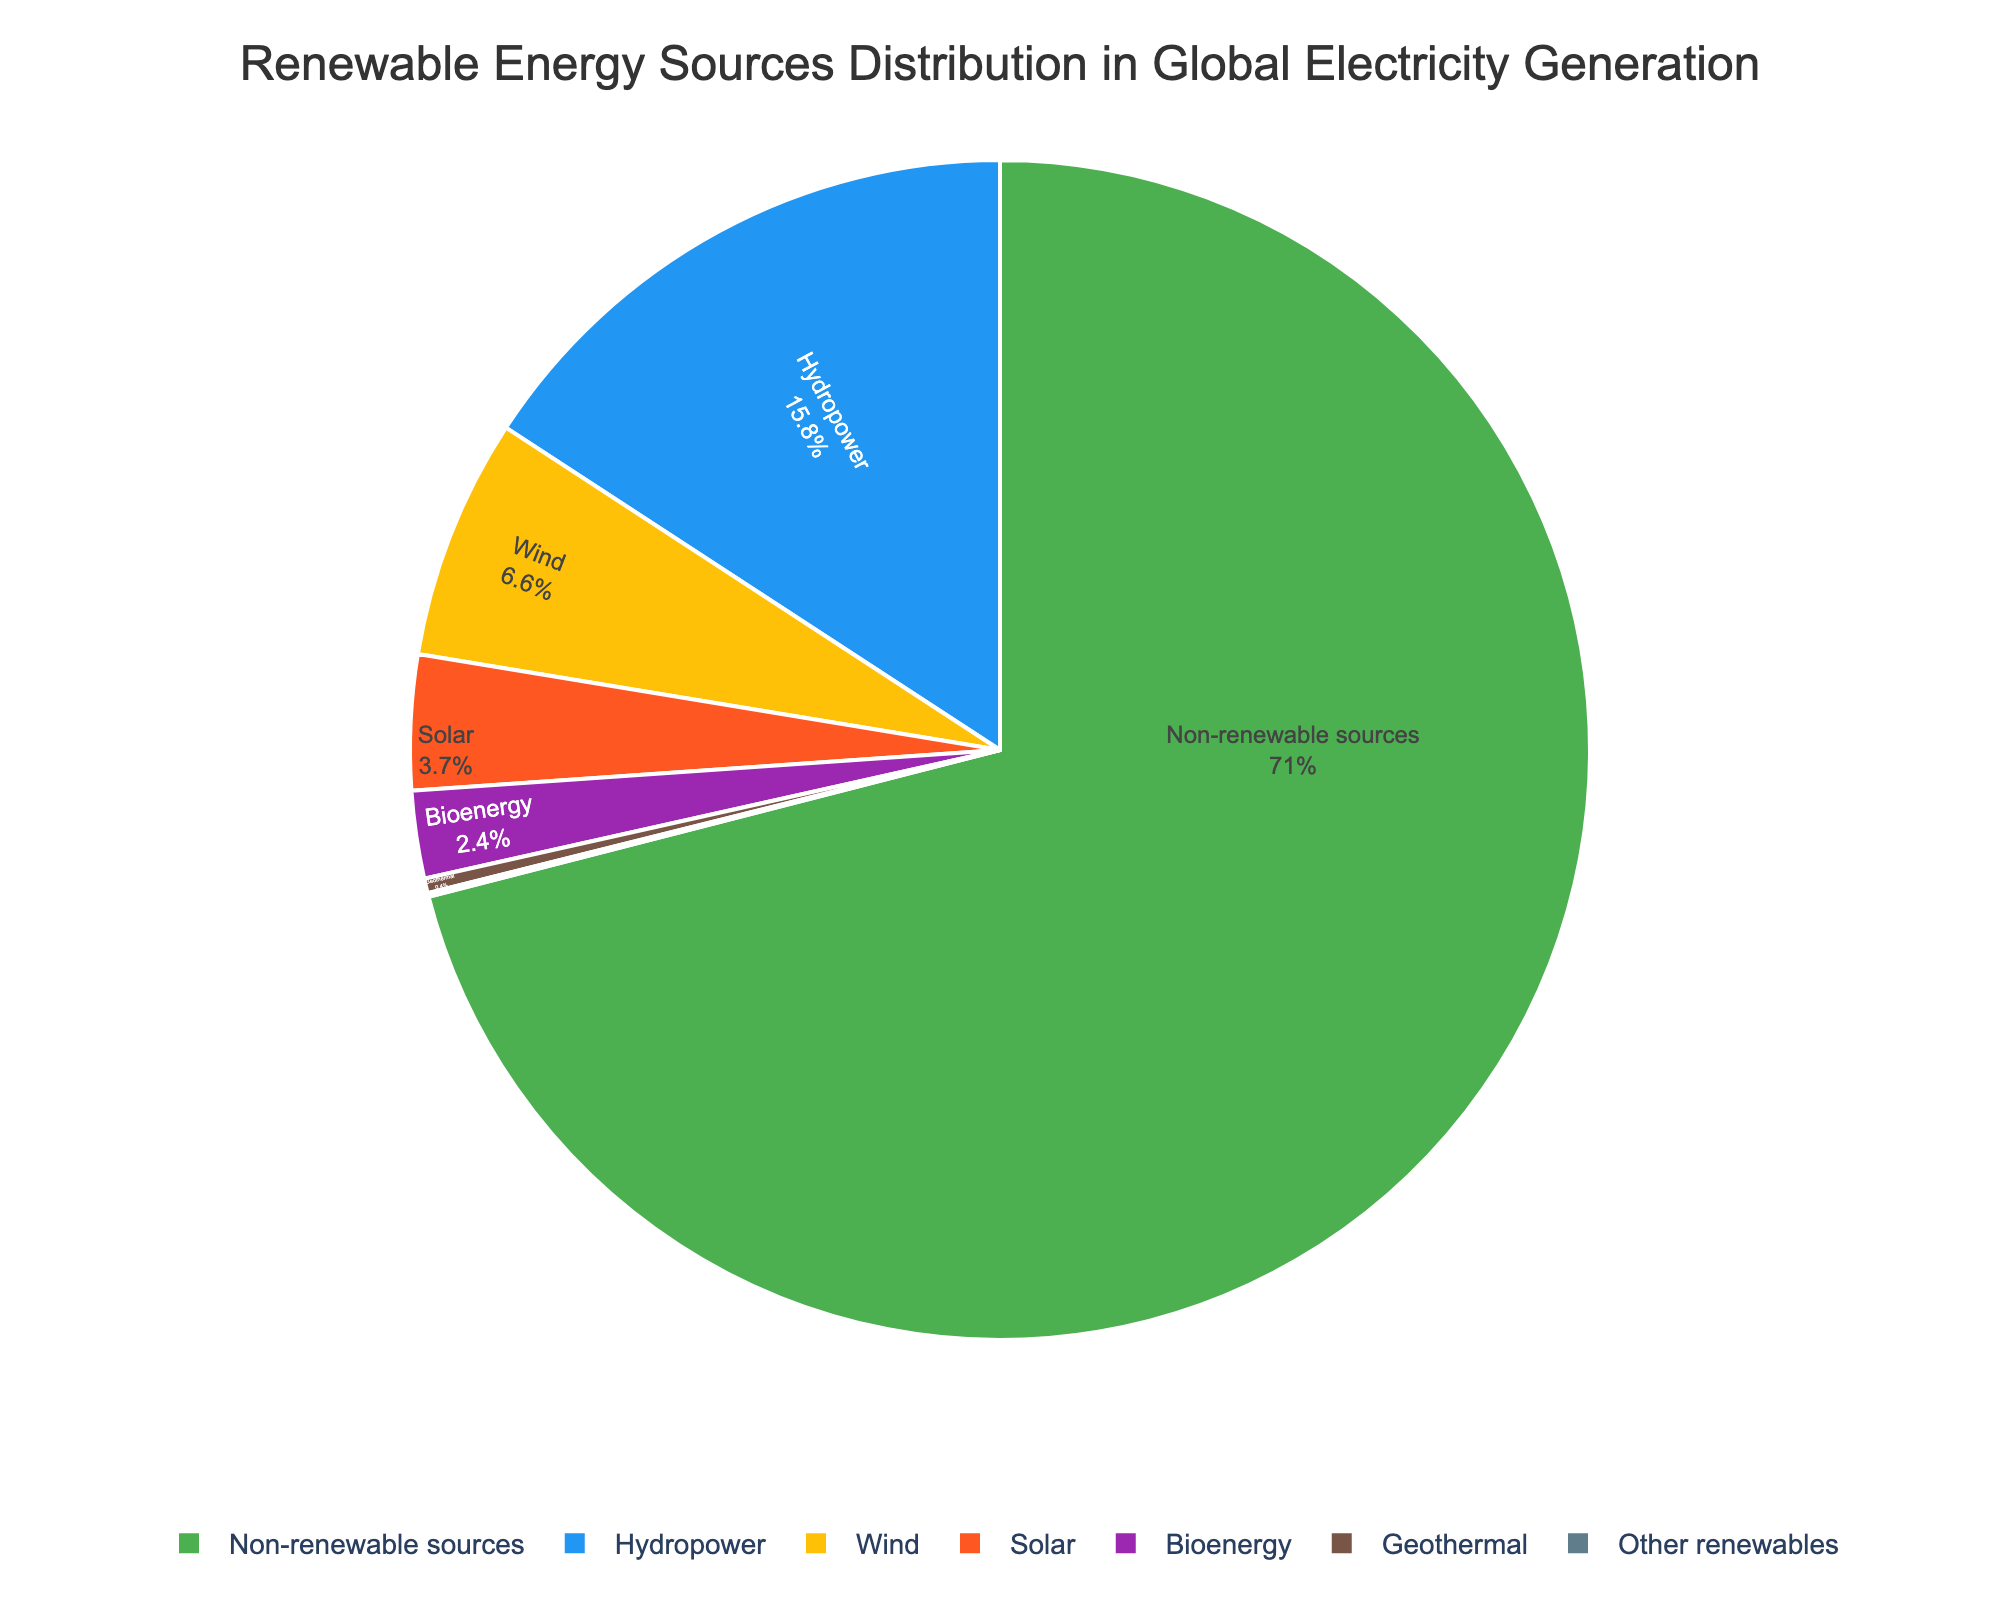Which renewable energy source has the highest percentage in the pie chart? The pie chart shows the percentages of different renewable energy sources in global electricity generation. Hydropower has the largest segment.
Answer: Hydropower Which renewable energy source has the smallest percentage in the pie chart? The pie chart indicates percentages of various renewable energy sources. 'Other renewables' has the smallest segment.
Answer: Other renewables How does the combined percentage of wind and solar compare to hydropower? First, add the percentages of wind (6.6%) and solar (3.7%) which total 10.3%. Then compare this with the percentage of hydropower (15.8%). Hydropower has a higher percentage.
Answer: Hydropower has a higher percentage What is the total percentage of renewable energy sources in the pie chart? Add all the percentages of renewable energy sources: Hydropower (15.8%) + Wind (6.6%) + Solar (3.7%) + Bioenergy (2.4%) + Geothermal (0.4%) + Other renewables (0.1%) = 29%.
Answer: 29% Which category occupies the most space in the pie chart, renewable sources or non-renewable sources? Compare the total percentage of renewable sources (29%) with the percentage of non-renewable sources (71%). Non-renewable sources occupy the largest space.
Answer: Non-renewable sources What is the combined percentage of sources other than wind and solar? Add all percentages except wind (6.6%) and solar (3.7%): 15.8 + 2.4 + 0.4 + 0.1 + 71 = 89.7.
Answer: 89.7% How many times larger is the percentage of non-renewable sources compared to bioenergy? Divide the percentage of non-renewable sources (71%) by the percentage of bioenergy (2.4%): 71 / 2.4 ≈ 29.58.
Answer: Approximately 29.58 times Which color represents wind energy in the pie chart? The color at the segment labeled 'Wind' in the pie chart is blue.
Answer: Blue Is the combined percentage of hydropower, wind, and solar greater than 25%? Add the percentages of hydropower (15.8%), wind (6.6%), and solar (3.7%): 15.8 + 6.6 + 3.7 = 26.1. This is greater than 25%.
Answer: Yes 